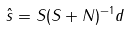Convert formula to latex. <formula><loc_0><loc_0><loc_500><loc_500>\hat { s } = S ( S + N ) ^ { - 1 } d</formula> 